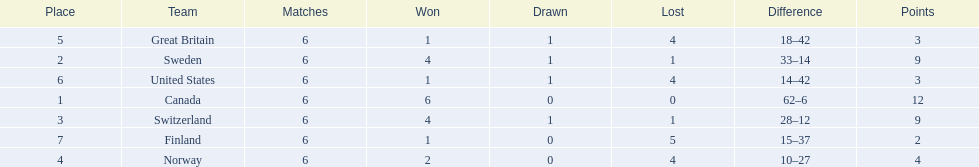What team placed after canada? Sweden. 